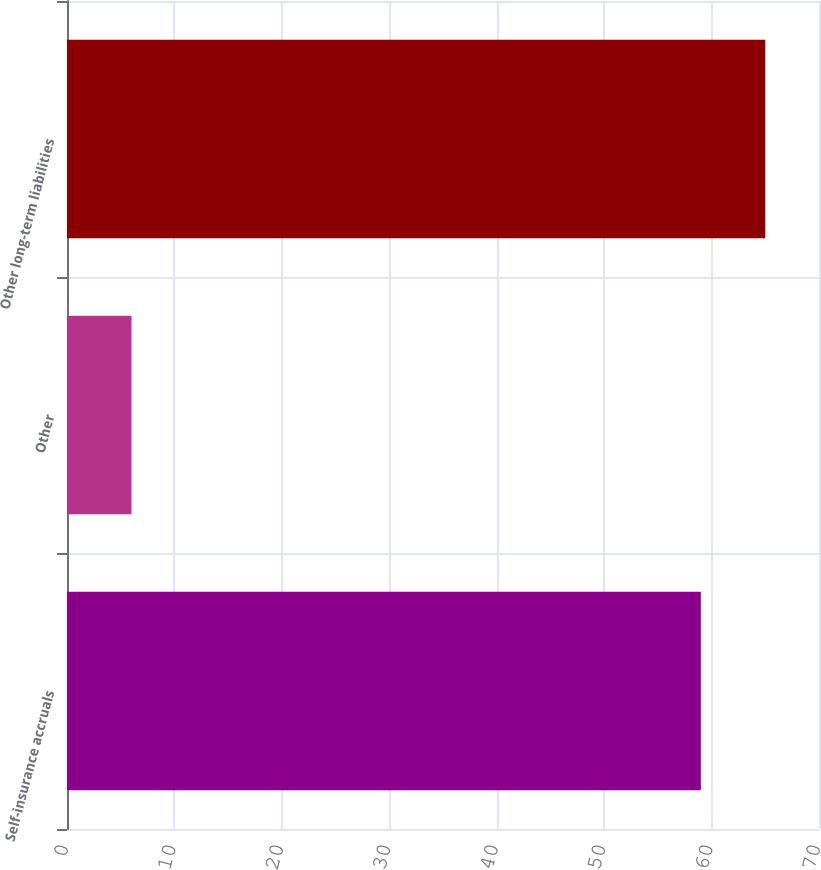Convert chart to OTSL. <chart><loc_0><loc_0><loc_500><loc_500><bar_chart><fcel>Self-insurance accruals<fcel>Other<fcel>Other long-term liabilities<nl><fcel>59<fcel>6<fcel>65<nl></chart> 